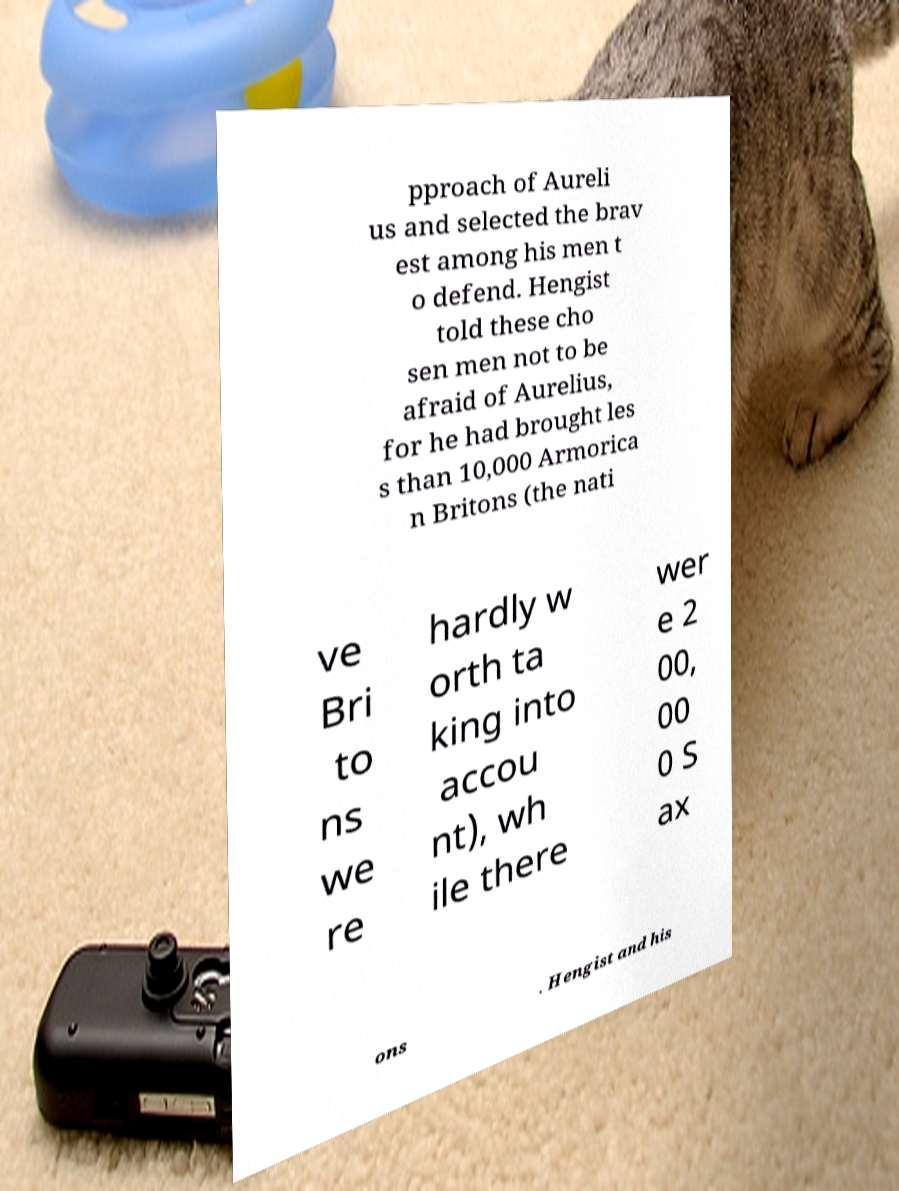Can you read and provide the text displayed in the image?This photo seems to have some interesting text. Can you extract and type it out for me? pproach of Aureli us and selected the brav est among his men t o defend. Hengist told these cho sen men not to be afraid of Aurelius, for he had brought les s than 10,000 Armorica n Britons (the nati ve Bri to ns we re hardly w orth ta king into accou nt), wh ile there wer e 2 00, 00 0 S ax ons . Hengist and his 